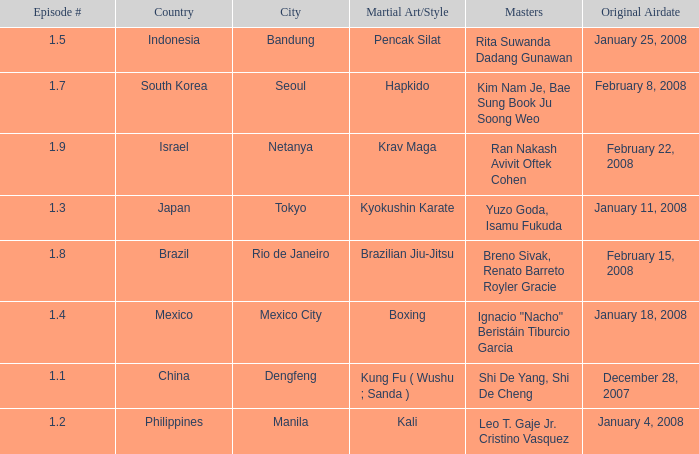When did the episode featuring a master using Brazilian jiu-jitsu air? February 15, 2008. 